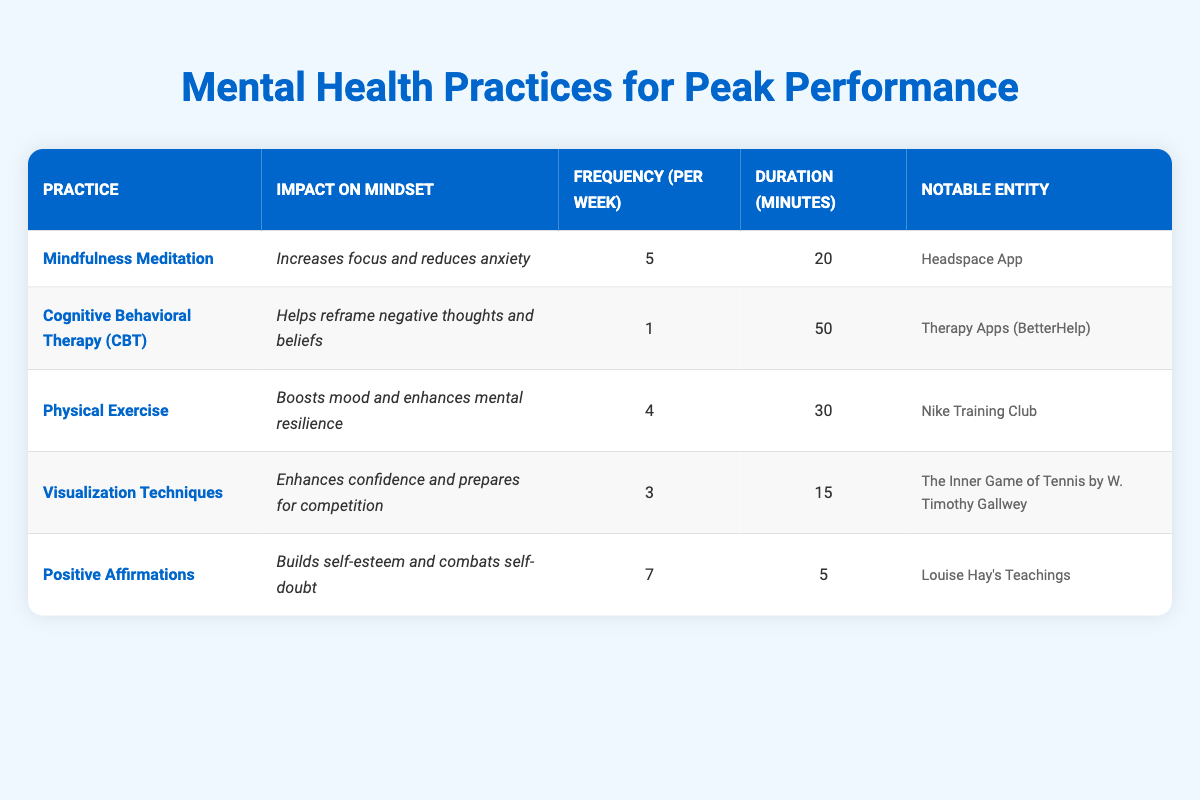What is the impact of Mindfulness Meditation on mindset? The table indicates that Mindfulness Meditation "Increases focus and reduces anxiety." Therefore, this is the direct impact it has on mindset.
Answer: Increases focus and reduces anxiety How many times per week do you practice Positive Affirmations? The table states the frequency of Positive Affirmations is "7" times per week.
Answer: 7 What is the average duration per session (in minutes) of the practices listed in the table? The durations are 20, 50, 30, 15, and 5 minutes respectively. Summing these gives 20 + 50 + 30 + 15 + 5 = 120 minutes. There are 5 practices, so the average duration is 120 / 5 = 24 minutes.
Answer: 24 Is it true that Visualization Techniques require a longer duration per session than Cognitive Behavioral Therapy? The duration of Visualization Techniques is 15 minutes, while Cognitive Behavioral Therapy is 50 minutes. Since 15 is less than 50, this statement is false.
Answer: No Which practice has the highest frequency of sessions per week? By comparing the frequencies: Mindfulness Meditation (5), CBT (1), Physical Exercise (4), Visualization Techniques (3), and Positive Affirmations (7), Positive Affirmations has the highest frequency of 7 sessions per week.
Answer: Positive Affirmations How many total minutes do you spend on practicing Physical Exercise per week? Physical Exercise is practiced 4 times per week, and each session lasts 30 minutes. Thus, the total is 4 * 30 = 120 minutes.
Answer: 120 minutes Which practices involve reducing anxiety and boosting mood? Referring to the information, Mindfulness Meditation reduces anxiety, and Physical Exercise boosts mood. Therefore, both these practices have the mentioned impacts on mindset.
Answer: Mindfulness Meditation and Physical Exercise What is the notable entity associated with Cognitive Behavioral Therapy? The table notes that the notable entity for Cognitive Behavioral Therapy is "Therapy Apps (BetterHelp)."
Answer: Therapy Apps (BetterHelp) 